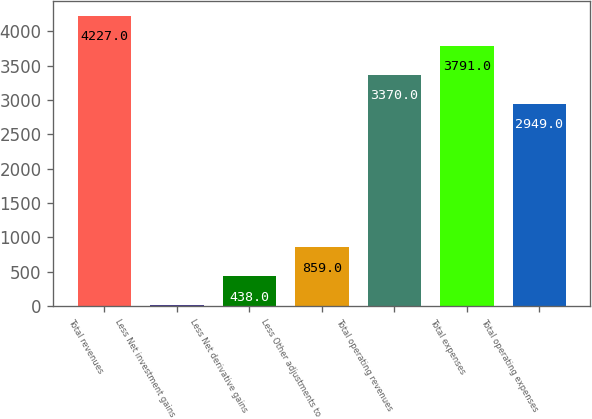<chart> <loc_0><loc_0><loc_500><loc_500><bar_chart><fcel>Total revenues<fcel>Less Net investment gains<fcel>Less Net derivative gains<fcel>Less Other adjustments to<fcel>Total operating revenues<fcel>Total expenses<fcel>Total operating expenses<nl><fcel>4227<fcel>17<fcel>438<fcel>859<fcel>3370<fcel>3791<fcel>2949<nl></chart> 